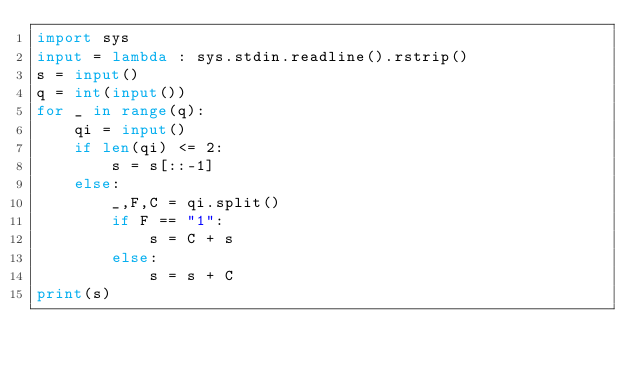<code> <loc_0><loc_0><loc_500><loc_500><_Python_>import sys
input = lambda : sys.stdin.readline().rstrip()
s = input()
q = int(input())
for _ in range(q):
    qi = input()
    if len(qi) <= 2:
        s = s[::-1]
    else:
        _,F,C = qi.split()
        if F == "1":
            s = C + s
        else:
            s = s + C           
print(s)</code> 